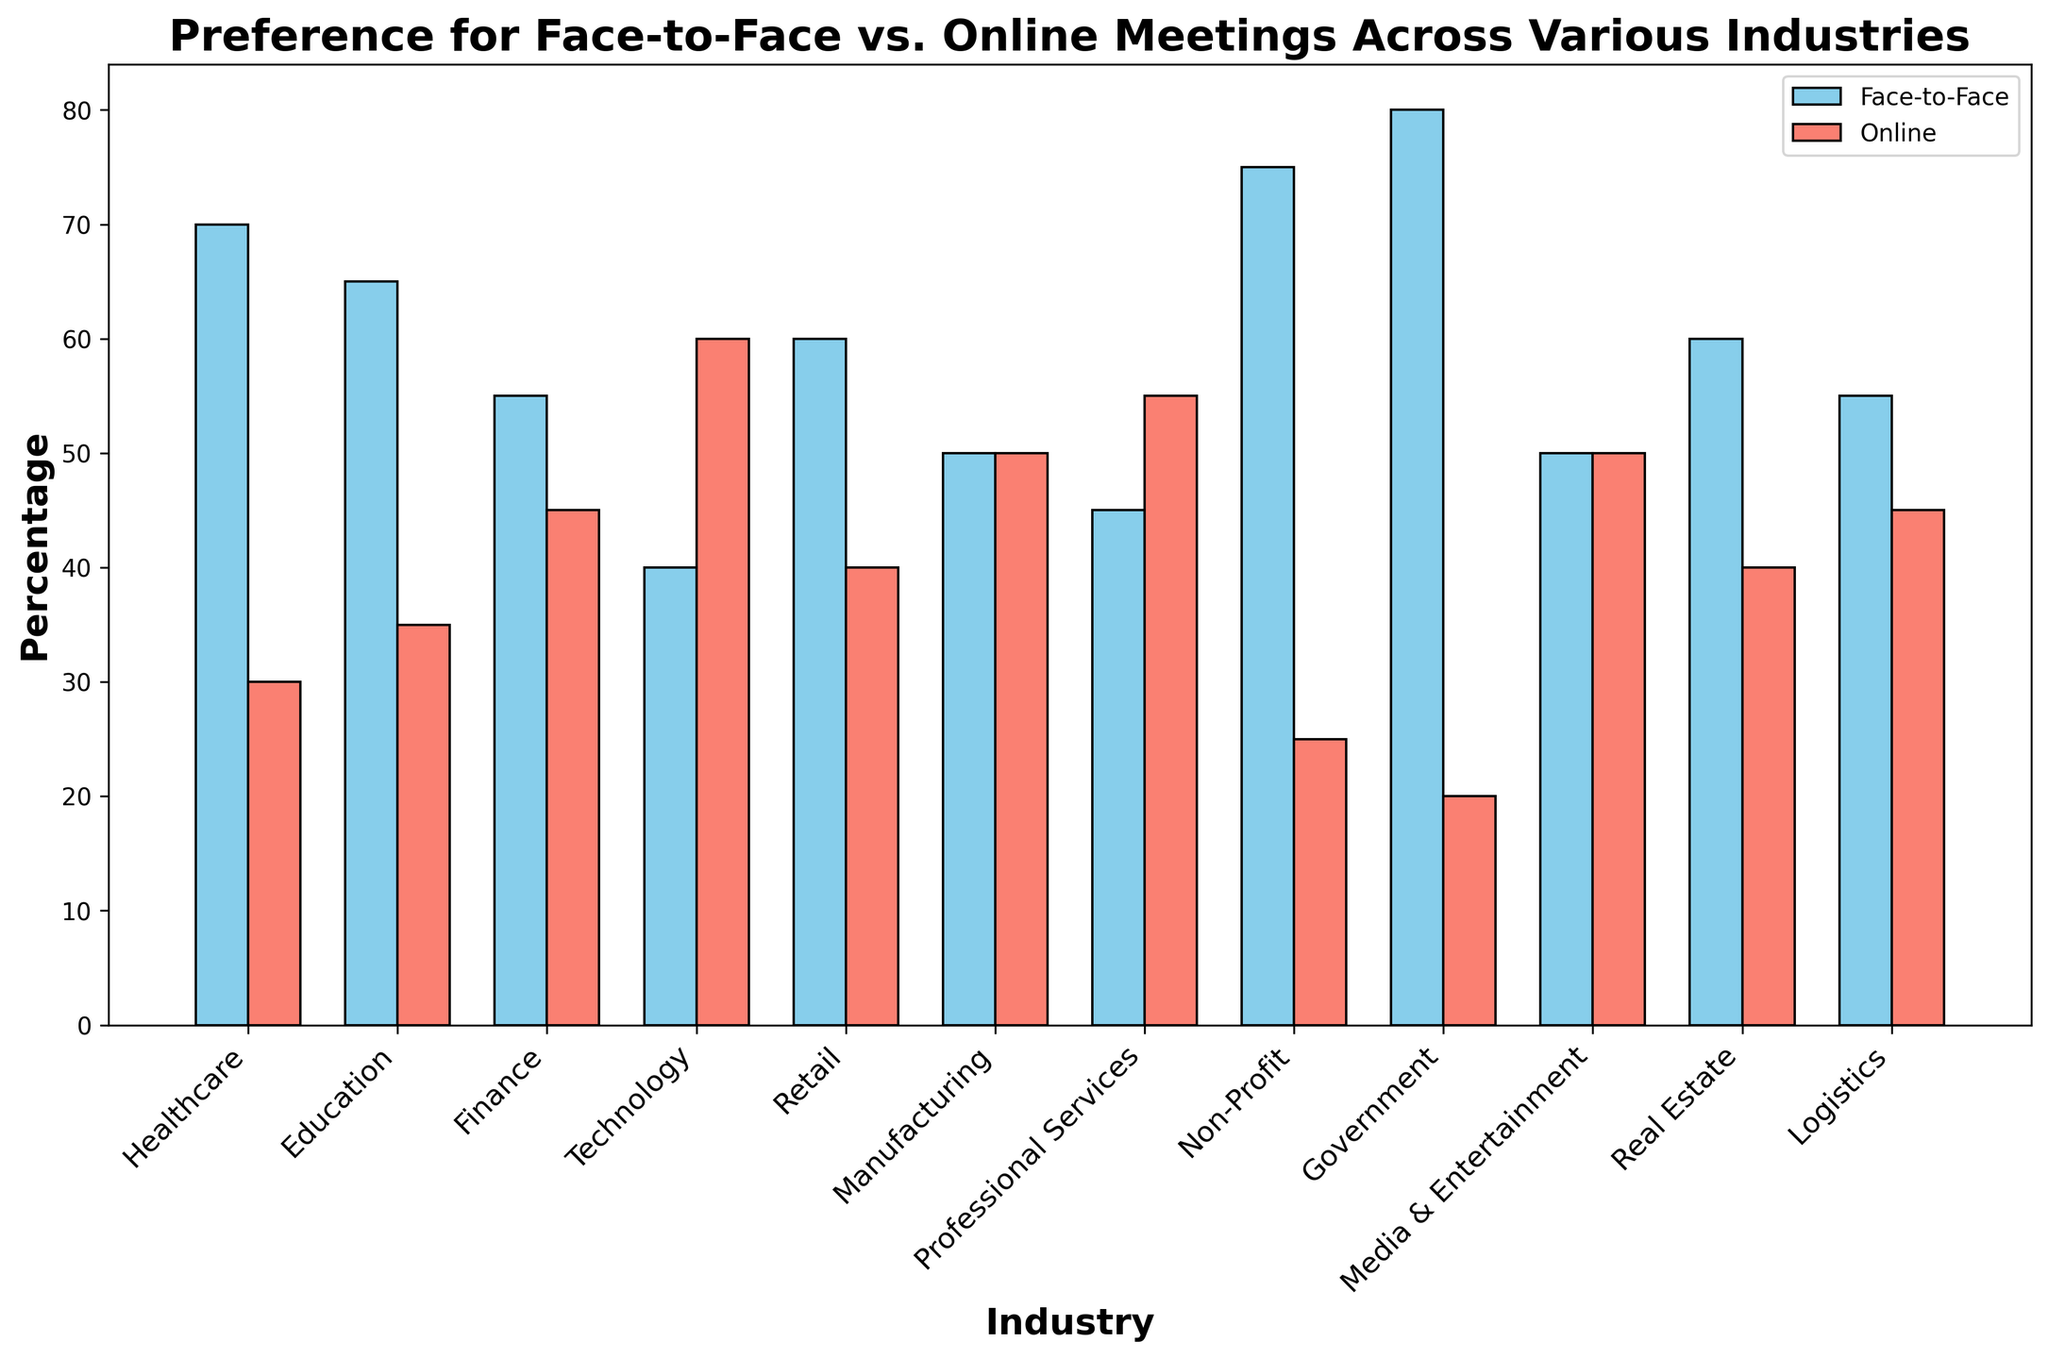What industry has the highest preference for face-to-face meetings? By looking at the tallest blue bar representing face-to-face meetings, we can identify the industry with the highest percentage. "Government" has the highest blue bar.
Answer: Government Which industry prefers online meetings the most? By identifying the tallest red bar representing online meetings, we see that the "Technology" industry has the highest percentage for online meetings.
Answer: Technology What is the difference in preference for face-to-face and online meetings in the "Finance" industry? The bar representing face-to-face in "Finance" is at 55, and the bar for online is at 45. The difference is 55 - 45.
Answer: 10 Which industries have an equal preference for face-to-face and online meetings? By identifying bars that have the same height for both face-to-face and online, the industries with equal preference are "Manufacturing" and "Media & Entertainment," both having 50% for each type of meeting.
Answer: Manufacturing, Media & Entertainment How many industries have a higher preference for online meetings than face-to-face meetings? By comparing the heights of the blue and red bars across all industries, we can see "Technology" and "Professional Services" have higher red bars than blue bars.
Answer: 2 In which industry is the preference for face-to-face meetings exactly 60%? By locating the blue bar that reaches the 60% mark, we find that "Retail" and "Real Estate" both have a 60% preference for face-to-face meetings.
Answer: Retail, Real Estate What is the average preference for face-to-face meetings across all industries? Sum up all the face-to-face percentages: 70 + 65 + 55 + 40 + 60 + 50 + 45 + 75 + 80 + 50 + 60 + 55 = 705. Then divide by the number of industries, which is 12: 705 / 12.
Answer: 58.75 Which industry has the lowest preference for online meetings? By locating the shortest red bar, we see that "Government" has the lowest preference for online meetings at 20%.
Answer: Government What is the cumulative preference percentage for face-to-face meetings in "Healthcare," "Education," and "Finance" industries? Add the face-to-face percentages for these industries: 70 (Healthcare) + 65 (Education) + 55 (Finance).
Answer: 190 